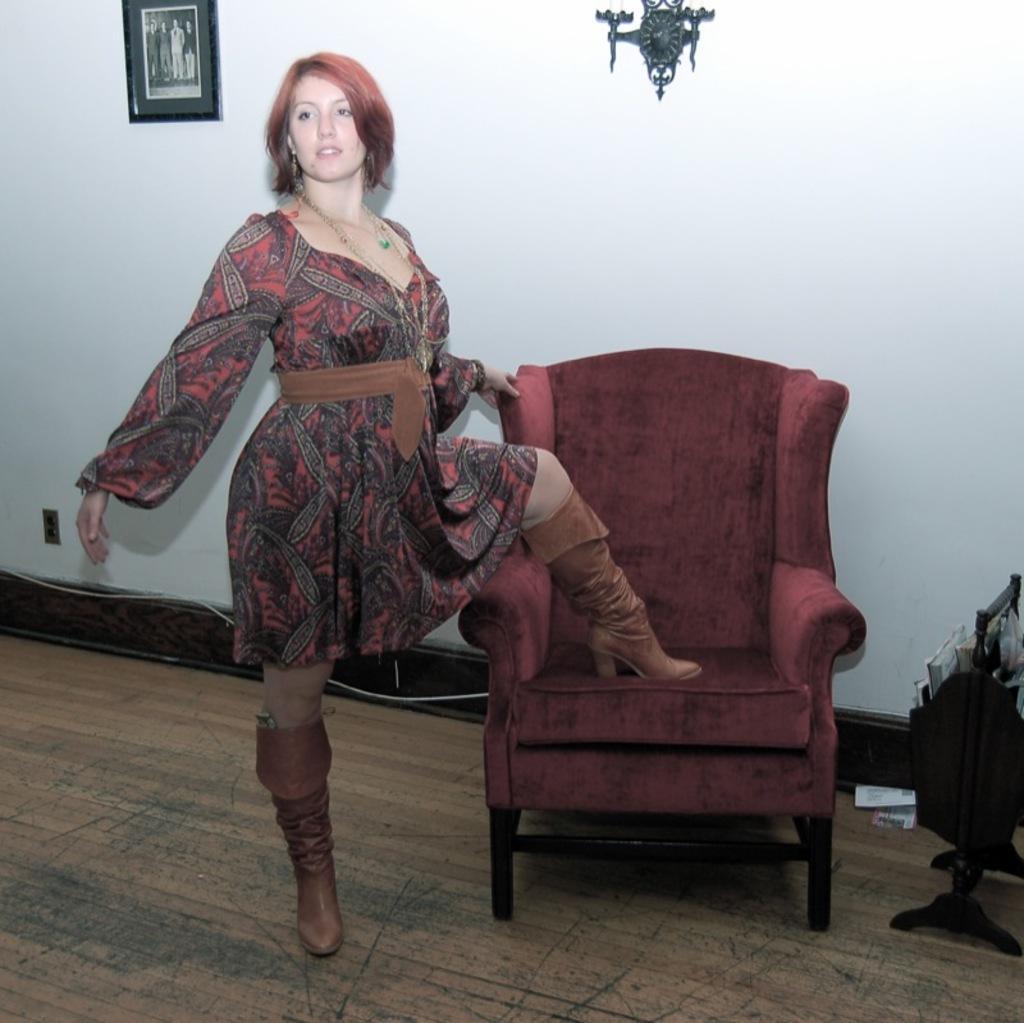Please provide a concise description of this image. In this image there is a woman standing and placed one of the legs on the couch, beside the couch there is a wooden structure and some books and papers are in it. In the background there is a frame and an object on the wall. 